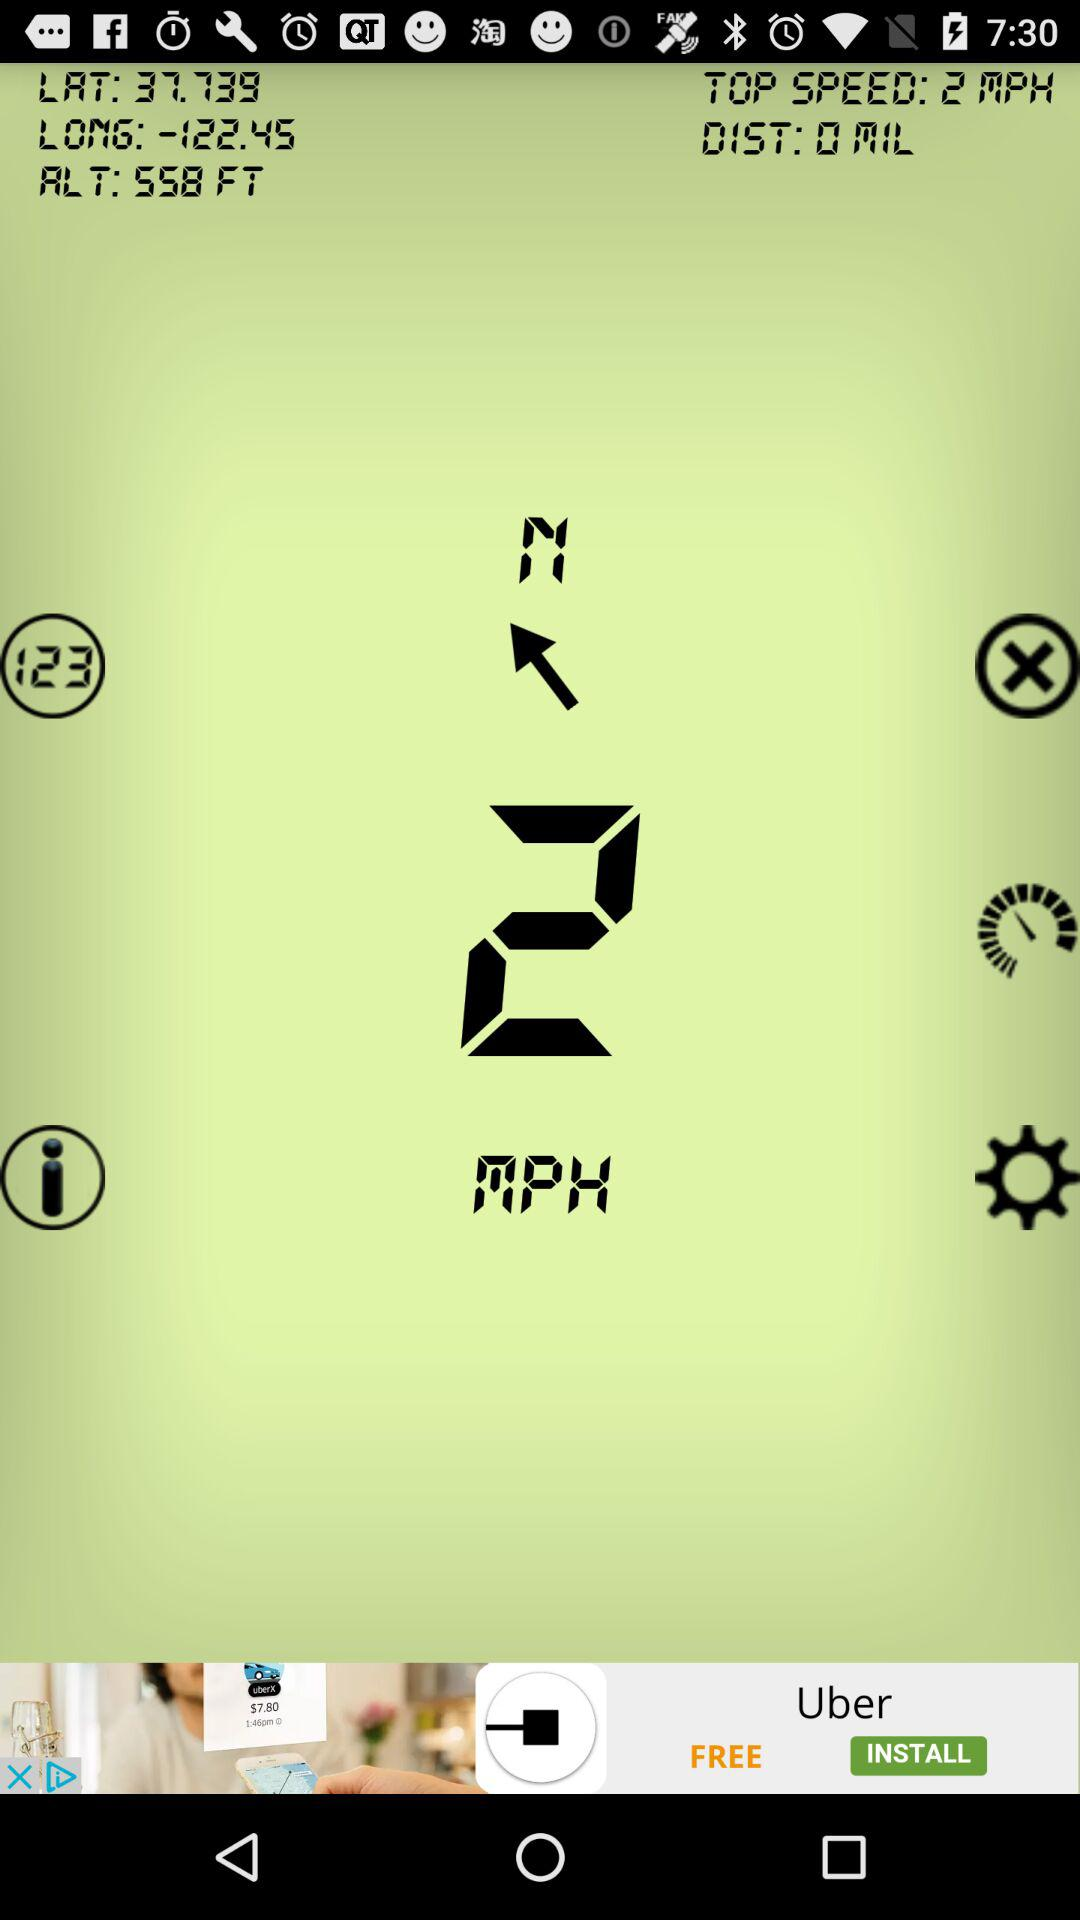How many miles have been driven?
Answer the question using a single word or phrase. 0 